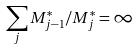Convert formula to latex. <formula><loc_0><loc_0><loc_500><loc_500>\sum _ { j } M _ { j - 1 } ^ { * } / M _ { j } ^ { * } = \infty</formula> 